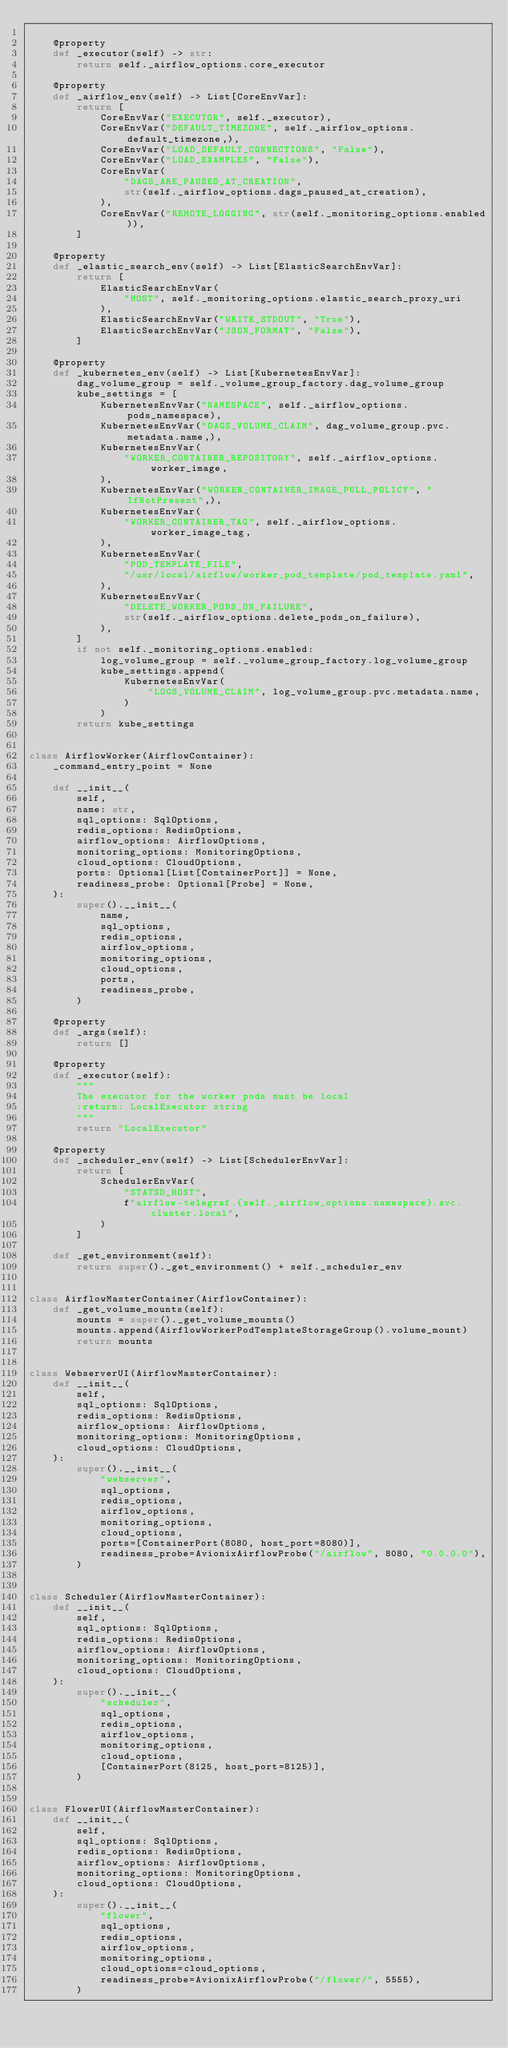<code> <loc_0><loc_0><loc_500><loc_500><_Python_>
    @property
    def _executor(self) -> str:
        return self._airflow_options.core_executor

    @property
    def _airflow_env(self) -> List[CoreEnvVar]:
        return [
            CoreEnvVar("EXECUTOR", self._executor),
            CoreEnvVar("DEFAULT_TIMEZONE", self._airflow_options.default_timezone,),
            CoreEnvVar("LOAD_DEFAULT_CONNECTIONS", "False"),
            CoreEnvVar("LOAD_EXAMPLES", "False"),
            CoreEnvVar(
                "DAGS_ARE_PAUSED_AT_CREATION",
                str(self._airflow_options.dags_paused_at_creation),
            ),
            CoreEnvVar("REMOTE_LOGGING", str(self._monitoring_options.enabled)),
        ]

    @property
    def _elastic_search_env(self) -> List[ElasticSearchEnvVar]:
        return [
            ElasticSearchEnvVar(
                "HOST", self._monitoring_options.elastic_search_proxy_uri
            ),
            ElasticSearchEnvVar("WRITE_STDOUT", "True"),
            ElasticSearchEnvVar("JSON_FORMAT", "False"),
        ]

    @property
    def _kubernetes_env(self) -> List[KubernetesEnvVar]:
        dag_volume_group = self._volume_group_factory.dag_volume_group
        kube_settings = [
            KubernetesEnvVar("NAMESPACE", self._airflow_options.pods_namespace),
            KubernetesEnvVar("DAGS_VOLUME_CLAIM", dag_volume_group.pvc.metadata.name,),
            KubernetesEnvVar(
                "WORKER_CONTAINER_REPOSITORY", self._airflow_options.worker_image,
            ),
            KubernetesEnvVar("WORKER_CONTAINER_IMAGE_PULL_POLICY", "IfNotPresent",),
            KubernetesEnvVar(
                "WORKER_CONTAINER_TAG", self._airflow_options.worker_image_tag,
            ),
            KubernetesEnvVar(
                "POD_TEMPLATE_FILE",
                "/usr/local/airflow/worker_pod_template/pod_template.yaml",
            ),
            KubernetesEnvVar(
                "DELETE_WORKER_PODS_ON_FAILURE",
                str(self._airflow_options.delete_pods_on_failure),
            ),
        ]
        if not self._monitoring_options.enabled:
            log_volume_group = self._volume_group_factory.log_volume_group
            kube_settings.append(
                KubernetesEnvVar(
                    "LOGS_VOLUME_CLAIM", log_volume_group.pvc.metadata.name,
                )
            )
        return kube_settings


class AirflowWorker(AirflowContainer):
    _command_entry_point = None

    def __init__(
        self,
        name: str,
        sql_options: SqlOptions,
        redis_options: RedisOptions,
        airflow_options: AirflowOptions,
        monitoring_options: MonitoringOptions,
        cloud_options: CloudOptions,
        ports: Optional[List[ContainerPort]] = None,
        readiness_probe: Optional[Probe] = None,
    ):
        super().__init__(
            name,
            sql_options,
            redis_options,
            airflow_options,
            monitoring_options,
            cloud_options,
            ports,
            readiness_probe,
        )

    @property
    def _args(self):
        return []

    @property
    def _executor(self):
        """
        The executor for the worker pods must be local
        :return: LocalExecutor string
        """
        return "LocalExecutor"

    @property
    def _scheduler_env(self) -> List[SchedulerEnvVar]:
        return [
            SchedulerEnvVar(
                "STATSD_HOST",
                f"airflow-telegraf.{self._airflow_options.namespace}.svc.cluster.local",
            )
        ]

    def _get_environment(self):
        return super()._get_environment() + self._scheduler_env


class AirflowMasterContainer(AirflowContainer):
    def _get_volume_mounts(self):
        mounts = super()._get_volume_mounts()
        mounts.append(AirflowWorkerPodTemplateStorageGroup().volume_mount)
        return mounts


class WebserverUI(AirflowMasterContainer):
    def __init__(
        self,
        sql_options: SqlOptions,
        redis_options: RedisOptions,
        airflow_options: AirflowOptions,
        monitoring_options: MonitoringOptions,
        cloud_options: CloudOptions,
    ):
        super().__init__(
            "webserver",
            sql_options,
            redis_options,
            airflow_options,
            monitoring_options,
            cloud_options,
            ports=[ContainerPort(8080, host_port=8080)],
            readiness_probe=AvionixAirflowProbe("/airflow", 8080, "0.0.0.0"),
        )


class Scheduler(AirflowMasterContainer):
    def __init__(
        self,
        sql_options: SqlOptions,
        redis_options: RedisOptions,
        airflow_options: AirflowOptions,
        monitoring_options: MonitoringOptions,
        cloud_options: CloudOptions,
    ):
        super().__init__(
            "scheduler",
            sql_options,
            redis_options,
            airflow_options,
            monitoring_options,
            cloud_options,
            [ContainerPort(8125, host_port=8125)],
        )


class FlowerUI(AirflowMasterContainer):
    def __init__(
        self,
        sql_options: SqlOptions,
        redis_options: RedisOptions,
        airflow_options: AirflowOptions,
        monitoring_options: MonitoringOptions,
        cloud_options: CloudOptions,
    ):
        super().__init__(
            "flower",
            sql_options,
            redis_options,
            airflow_options,
            monitoring_options,
            cloud_options=cloud_options,
            readiness_probe=AvionixAirflowProbe("/flower/", 5555),
        )
</code> 